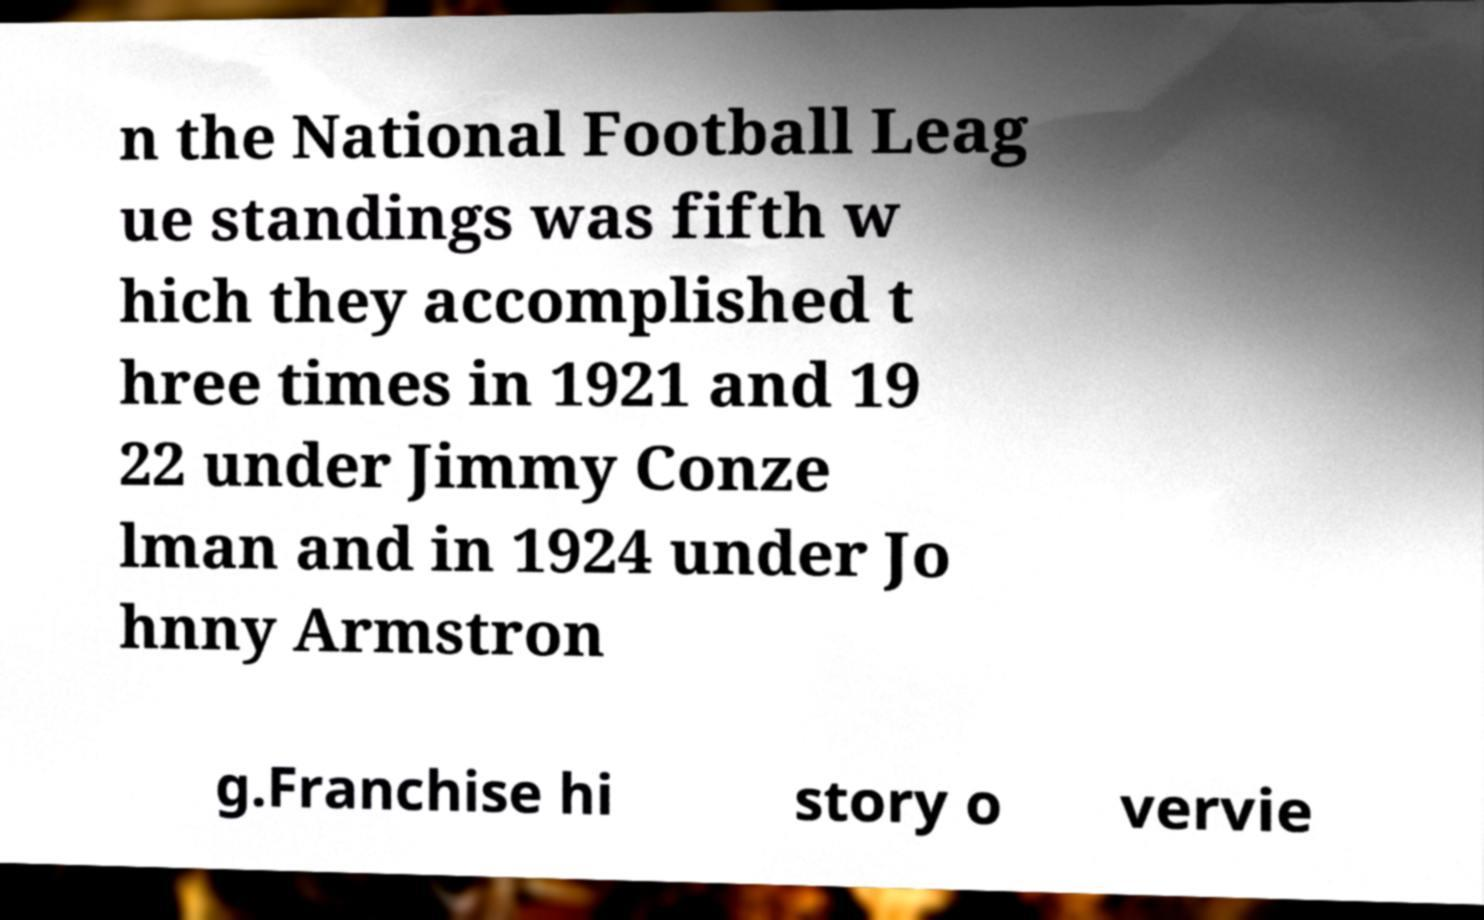Could you extract and type out the text from this image? n the National Football Leag ue standings was fifth w hich they accomplished t hree times in 1921 and 19 22 under Jimmy Conze lman and in 1924 under Jo hnny Armstron g.Franchise hi story o vervie 